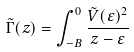<formula> <loc_0><loc_0><loc_500><loc_500>\tilde { \Gamma } ( z ) = \int ^ { 0 } _ { - B } \frac { \tilde { V } ( \varepsilon ) ^ { 2 } } { z - \varepsilon }</formula> 